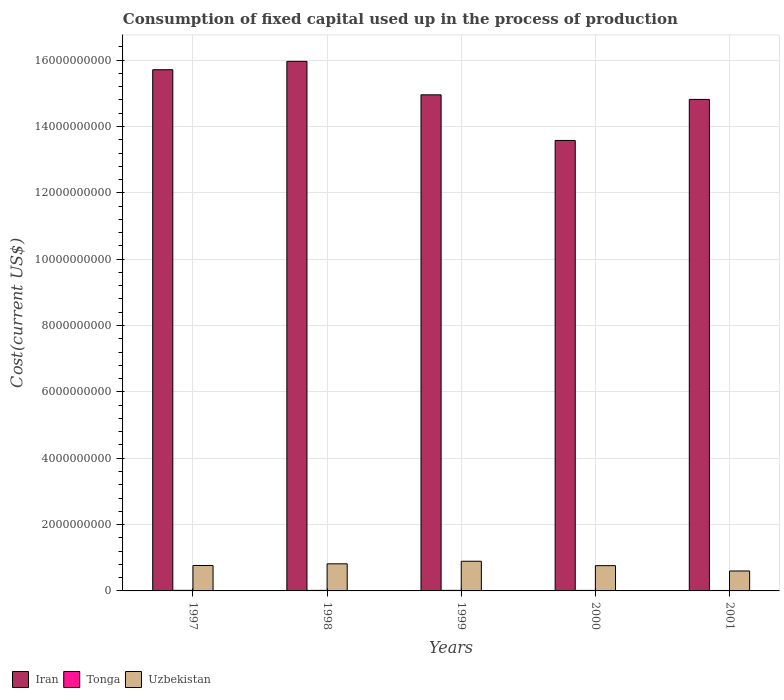How many different coloured bars are there?
Offer a very short reply. 3. Are the number of bars per tick equal to the number of legend labels?
Make the answer very short. Yes. How many bars are there on the 4th tick from the right?
Ensure brevity in your answer.  3. In how many cases, is the number of bars for a given year not equal to the number of legend labels?
Provide a short and direct response. 0. What is the amount consumed in the process of production in Iran in 2001?
Keep it short and to the point. 1.48e+1. Across all years, what is the maximum amount consumed in the process of production in Iran?
Give a very brief answer. 1.60e+1. Across all years, what is the minimum amount consumed in the process of production in Uzbekistan?
Keep it short and to the point. 6.01e+08. In which year was the amount consumed in the process of production in Iran minimum?
Keep it short and to the point. 2000. What is the total amount consumed in the process of production in Iran in the graph?
Keep it short and to the point. 7.50e+1. What is the difference between the amount consumed in the process of production in Uzbekistan in 1997 and that in 2001?
Make the answer very short. 1.64e+08. What is the difference between the amount consumed in the process of production in Uzbekistan in 1997 and the amount consumed in the process of production in Iran in 2001?
Offer a very short reply. -1.40e+1. What is the average amount consumed in the process of production in Iran per year?
Offer a terse response. 1.50e+1. In the year 1998, what is the difference between the amount consumed in the process of production in Tonga and amount consumed in the process of production in Uzbekistan?
Your answer should be very brief. -8.01e+08. What is the ratio of the amount consumed in the process of production in Iran in 2000 to that in 2001?
Your response must be concise. 0.92. What is the difference between the highest and the second highest amount consumed in the process of production in Iran?
Ensure brevity in your answer.  2.52e+08. What is the difference between the highest and the lowest amount consumed in the process of production in Uzbekistan?
Keep it short and to the point. 2.93e+08. What does the 2nd bar from the left in 1998 represents?
Make the answer very short. Tonga. What does the 1st bar from the right in 1999 represents?
Make the answer very short. Uzbekistan. Is it the case that in every year, the sum of the amount consumed in the process of production in Tonga and amount consumed in the process of production in Iran is greater than the amount consumed in the process of production in Uzbekistan?
Give a very brief answer. Yes. Does the graph contain grids?
Offer a terse response. Yes. How are the legend labels stacked?
Your answer should be very brief. Horizontal. What is the title of the graph?
Offer a terse response. Consumption of fixed capital used up in the process of production. What is the label or title of the X-axis?
Make the answer very short. Years. What is the label or title of the Y-axis?
Offer a very short reply. Cost(current US$). What is the Cost(current US$) in Iran in 1997?
Provide a short and direct response. 1.57e+1. What is the Cost(current US$) of Tonga in 1997?
Keep it short and to the point. 1.72e+07. What is the Cost(current US$) of Uzbekistan in 1997?
Your answer should be compact. 7.66e+08. What is the Cost(current US$) of Iran in 1998?
Your answer should be compact. 1.60e+1. What is the Cost(current US$) of Tonga in 1998?
Your answer should be compact. 1.61e+07. What is the Cost(current US$) in Uzbekistan in 1998?
Your response must be concise. 8.17e+08. What is the Cost(current US$) of Iran in 1999?
Give a very brief answer. 1.50e+1. What is the Cost(current US$) of Tonga in 1999?
Provide a short and direct response. 1.65e+07. What is the Cost(current US$) of Uzbekistan in 1999?
Keep it short and to the point. 8.94e+08. What is the Cost(current US$) of Iran in 2000?
Your response must be concise. 1.36e+1. What is the Cost(current US$) of Tonga in 2000?
Keep it short and to the point. 1.59e+07. What is the Cost(current US$) in Uzbekistan in 2000?
Your answer should be compact. 7.62e+08. What is the Cost(current US$) in Iran in 2001?
Offer a very short reply. 1.48e+1. What is the Cost(current US$) in Tonga in 2001?
Keep it short and to the point. 1.39e+07. What is the Cost(current US$) in Uzbekistan in 2001?
Offer a terse response. 6.01e+08. Across all years, what is the maximum Cost(current US$) in Iran?
Ensure brevity in your answer.  1.60e+1. Across all years, what is the maximum Cost(current US$) in Tonga?
Your response must be concise. 1.72e+07. Across all years, what is the maximum Cost(current US$) of Uzbekistan?
Your response must be concise. 8.94e+08. Across all years, what is the minimum Cost(current US$) of Iran?
Provide a short and direct response. 1.36e+1. Across all years, what is the minimum Cost(current US$) in Tonga?
Offer a terse response. 1.39e+07. Across all years, what is the minimum Cost(current US$) in Uzbekistan?
Your response must be concise. 6.01e+08. What is the total Cost(current US$) in Iran in the graph?
Provide a short and direct response. 7.50e+1. What is the total Cost(current US$) of Tonga in the graph?
Offer a very short reply. 7.96e+07. What is the total Cost(current US$) of Uzbekistan in the graph?
Your answer should be compact. 3.84e+09. What is the difference between the Cost(current US$) of Iran in 1997 and that in 1998?
Make the answer very short. -2.52e+08. What is the difference between the Cost(current US$) in Tonga in 1997 and that in 1998?
Keep it short and to the point. 1.14e+06. What is the difference between the Cost(current US$) of Uzbekistan in 1997 and that in 1998?
Your response must be concise. -5.13e+07. What is the difference between the Cost(current US$) of Iran in 1997 and that in 1999?
Ensure brevity in your answer.  7.57e+08. What is the difference between the Cost(current US$) of Tonga in 1997 and that in 1999?
Give a very brief answer. 7.30e+05. What is the difference between the Cost(current US$) in Uzbekistan in 1997 and that in 1999?
Offer a terse response. -1.29e+08. What is the difference between the Cost(current US$) of Iran in 1997 and that in 2000?
Offer a very short reply. 2.13e+09. What is the difference between the Cost(current US$) in Tonga in 1997 and that in 2000?
Ensure brevity in your answer.  1.25e+06. What is the difference between the Cost(current US$) of Uzbekistan in 1997 and that in 2000?
Your answer should be compact. 4.04e+06. What is the difference between the Cost(current US$) of Iran in 1997 and that in 2001?
Your answer should be compact. 8.96e+08. What is the difference between the Cost(current US$) in Tonga in 1997 and that in 2001?
Provide a short and direct response. 3.28e+06. What is the difference between the Cost(current US$) of Uzbekistan in 1997 and that in 2001?
Offer a terse response. 1.64e+08. What is the difference between the Cost(current US$) of Iran in 1998 and that in 1999?
Keep it short and to the point. 1.01e+09. What is the difference between the Cost(current US$) of Tonga in 1998 and that in 1999?
Offer a very short reply. -4.14e+05. What is the difference between the Cost(current US$) in Uzbekistan in 1998 and that in 1999?
Provide a short and direct response. -7.76e+07. What is the difference between the Cost(current US$) of Iran in 1998 and that in 2000?
Offer a very short reply. 2.38e+09. What is the difference between the Cost(current US$) in Tonga in 1998 and that in 2000?
Ensure brevity in your answer.  1.09e+05. What is the difference between the Cost(current US$) in Uzbekistan in 1998 and that in 2000?
Offer a very short reply. 5.54e+07. What is the difference between the Cost(current US$) in Iran in 1998 and that in 2001?
Your answer should be compact. 1.15e+09. What is the difference between the Cost(current US$) of Tonga in 1998 and that in 2001?
Your answer should be very brief. 2.14e+06. What is the difference between the Cost(current US$) in Uzbekistan in 1998 and that in 2001?
Make the answer very short. 2.16e+08. What is the difference between the Cost(current US$) in Iran in 1999 and that in 2000?
Offer a terse response. 1.38e+09. What is the difference between the Cost(current US$) of Tonga in 1999 and that in 2000?
Make the answer very short. 5.22e+05. What is the difference between the Cost(current US$) in Uzbekistan in 1999 and that in 2000?
Provide a succinct answer. 1.33e+08. What is the difference between the Cost(current US$) of Iran in 1999 and that in 2001?
Your response must be concise. 1.39e+08. What is the difference between the Cost(current US$) in Tonga in 1999 and that in 2001?
Your response must be concise. 2.55e+06. What is the difference between the Cost(current US$) of Uzbekistan in 1999 and that in 2001?
Provide a short and direct response. 2.93e+08. What is the difference between the Cost(current US$) in Iran in 2000 and that in 2001?
Provide a short and direct response. -1.24e+09. What is the difference between the Cost(current US$) in Tonga in 2000 and that in 2001?
Provide a succinct answer. 2.03e+06. What is the difference between the Cost(current US$) of Uzbekistan in 2000 and that in 2001?
Offer a terse response. 1.60e+08. What is the difference between the Cost(current US$) in Iran in 1997 and the Cost(current US$) in Tonga in 1998?
Your response must be concise. 1.57e+1. What is the difference between the Cost(current US$) of Iran in 1997 and the Cost(current US$) of Uzbekistan in 1998?
Your answer should be very brief. 1.49e+1. What is the difference between the Cost(current US$) of Tonga in 1997 and the Cost(current US$) of Uzbekistan in 1998?
Offer a very short reply. -8.00e+08. What is the difference between the Cost(current US$) in Iran in 1997 and the Cost(current US$) in Tonga in 1999?
Your answer should be compact. 1.57e+1. What is the difference between the Cost(current US$) of Iran in 1997 and the Cost(current US$) of Uzbekistan in 1999?
Provide a short and direct response. 1.48e+1. What is the difference between the Cost(current US$) in Tonga in 1997 and the Cost(current US$) in Uzbekistan in 1999?
Keep it short and to the point. -8.77e+08. What is the difference between the Cost(current US$) of Iran in 1997 and the Cost(current US$) of Tonga in 2000?
Your response must be concise. 1.57e+1. What is the difference between the Cost(current US$) in Iran in 1997 and the Cost(current US$) in Uzbekistan in 2000?
Ensure brevity in your answer.  1.49e+1. What is the difference between the Cost(current US$) of Tonga in 1997 and the Cost(current US$) of Uzbekistan in 2000?
Provide a succinct answer. -7.44e+08. What is the difference between the Cost(current US$) in Iran in 1997 and the Cost(current US$) in Tonga in 2001?
Give a very brief answer. 1.57e+1. What is the difference between the Cost(current US$) in Iran in 1997 and the Cost(current US$) in Uzbekistan in 2001?
Make the answer very short. 1.51e+1. What is the difference between the Cost(current US$) in Tonga in 1997 and the Cost(current US$) in Uzbekistan in 2001?
Offer a terse response. -5.84e+08. What is the difference between the Cost(current US$) in Iran in 1998 and the Cost(current US$) in Tonga in 1999?
Make the answer very short. 1.59e+1. What is the difference between the Cost(current US$) of Iran in 1998 and the Cost(current US$) of Uzbekistan in 1999?
Provide a succinct answer. 1.51e+1. What is the difference between the Cost(current US$) in Tonga in 1998 and the Cost(current US$) in Uzbekistan in 1999?
Offer a terse response. -8.78e+08. What is the difference between the Cost(current US$) in Iran in 1998 and the Cost(current US$) in Tonga in 2000?
Give a very brief answer. 1.59e+1. What is the difference between the Cost(current US$) of Iran in 1998 and the Cost(current US$) of Uzbekistan in 2000?
Make the answer very short. 1.52e+1. What is the difference between the Cost(current US$) in Tonga in 1998 and the Cost(current US$) in Uzbekistan in 2000?
Make the answer very short. -7.45e+08. What is the difference between the Cost(current US$) of Iran in 1998 and the Cost(current US$) of Tonga in 2001?
Keep it short and to the point. 1.59e+1. What is the difference between the Cost(current US$) in Iran in 1998 and the Cost(current US$) in Uzbekistan in 2001?
Ensure brevity in your answer.  1.54e+1. What is the difference between the Cost(current US$) of Tonga in 1998 and the Cost(current US$) of Uzbekistan in 2001?
Ensure brevity in your answer.  -5.85e+08. What is the difference between the Cost(current US$) of Iran in 1999 and the Cost(current US$) of Tonga in 2000?
Your answer should be compact. 1.49e+1. What is the difference between the Cost(current US$) of Iran in 1999 and the Cost(current US$) of Uzbekistan in 2000?
Provide a succinct answer. 1.42e+1. What is the difference between the Cost(current US$) in Tonga in 1999 and the Cost(current US$) in Uzbekistan in 2000?
Offer a terse response. -7.45e+08. What is the difference between the Cost(current US$) of Iran in 1999 and the Cost(current US$) of Tonga in 2001?
Provide a succinct answer. 1.49e+1. What is the difference between the Cost(current US$) in Iran in 1999 and the Cost(current US$) in Uzbekistan in 2001?
Give a very brief answer. 1.44e+1. What is the difference between the Cost(current US$) in Tonga in 1999 and the Cost(current US$) in Uzbekistan in 2001?
Your answer should be very brief. -5.85e+08. What is the difference between the Cost(current US$) in Iran in 2000 and the Cost(current US$) in Tonga in 2001?
Offer a very short reply. 1.36e+1. What is the difference between the Cost(current US$) in Iran in 2000 and the Cost(current US$) in Uzbekistan in 2001?
Give a very brief answer. 1.30e+1. What is the difference between the Cost(current US$) of Tonga in 2000 and the Cost(current US$) of Uzbekistan in 2001?
Provide a succinct answer. -5.85e+08. What is the average Cost(current US$) of Iran per year?
Your response must be concise. 1.50e+1. What is the average Cost(current US$) of Tonga per year?
Your answer should be compact. 1.59e+07. What is the average Cost(current US$) of Uzbekistan per year?
Keep it short and to the point. 7.68e+08. In the year 1997, what is the difference between the Cost(current US$) of Iran and Cost(current US$) of Tonga?
Keep it short and to the point. 1.57e+1. In the year 1997, what is the difference between the Cost(current US$) of Iran and Cost(current US$) of Uzbekistan?
Give a very brief answer. 1.49e+1. In the year 1997, what is the difference between the Cost(current US$) in Tonga and Cost(current US$) in Uzbekistan?
Ensure brevity in your answer.  -7.48e+08. In the year 1998, what is the difference between the Cost(current US$) of Iran and Cost(current US$) of Tonga?
Your response must be concise. 1.59e+1. In the year 1998, what is the difference between the Cost(current US$) of Iran and Cost(current US$) of Uzbekistan?
Ensure brevity in your answer.  1.51e+1. In the year 1998, what is the difference between the Cost(current US$) of Tonga and Cost(current US$) of Uzbekistan?
Ensure brevity in your answer.  -8.01e+08. In the year 1999, what is the difference between the Cost(current US$) of Iran and Cost(current US$) of Tonga?
Your answer should be compact. 1.49e+1. In the year 1999, what is the difference between the Cost(current US$) in Iran and Cost(current US$) in Uzbekistan?
Ensure brevity in your answer.  1.41e+1. In the year 1999, what is the difference between the Cost(current US$) of Tonga and Cost(current US$) of Uzbekistan?
Your answer should be very brief. -8.78e+08. In the year 2000, what is the difference between the Cost(current US$) in Iran and Cost(current US$) in Tonga?
Offer a terse response. 1.36e+1. In the year 2000, what is the difference between the Cost(current US$) of Iran and Cost(current US$) of Uzbekistan?
Offer a very short reply. 1.28e+1. In the year 2000, what is the difference between the Cost(current US$) of Tonga and Cost(current US$) of Uzbekistan?
Your answer should be very brief. -7.46e+08. In the year 2001, what is the difference between the Cost(current US$) in Iran and Cost(current US$) in Tonga?
Your answer should be compact. 1.48e+1. In the year 2001, what is the difference between the Cost(current US$) of Iran and Cost(current US$) of Uzbekistan?
Make the answer very short. 1.42e+1. In the year 2001, what is the difference between the Cost(current US$) of Tonga and Cost(current US$) of Uzbekistan?
Ensure brevity in your answer.  -5.87e+08. What is the ratio of the Cost(current US$) of Iran in 1997 to that in 1998?
Keep it short and to the point. 0.98. What is the ratio of the Cost(current US$) of Tonga in 1997 to that in 1998?
Your answer should be compact. 1.07. What is the ratio of the Cost(current US$) of Uzbekistan in 1997 to that in 1998?
Ensure brevity in your answer.  0.94. What is the ratio of the Cost(current US$) of Iran in 1997 to that in 1999?
Your answer should be compact. 1.05. What is the ratio of the Cost(current US$) in Tonga in 1997 to that in 1999?
Offer a terse response. 1.04. What is the ratio of the Cost(current US$) in Uzbekistan in 1997 to that in 1999?
Offer a terse response. 0.86. What is the ratio of the Cost(current US$) in Iran in 1997 to that in 2000?
Give a very brief answer. 1.16. What is the ratio of the Cost(current US$) of Tonga in 1997 to that in 2000?
Offer a terse response. 1.08. What is the ratio of the Cost(current US$) in Iran in 1997 to that in 2001?
Your answer should be very brief. 1.06. What is the ratio of the Cost(current US$) of Tonga in 1997 to that in 2001?
Provide a succinct answer. 1.24. What is the ratio of the Cost(current US$) of Uzbekistan in 1997 to that in 2001?
Offer a terse response. 1.27. What is the ratio of the Cost(current US$) in Iran in 1998 to that in 1999?
Give a very brief answer. 1.07. What is the ratio of the Cost(current US$) of Tonga in 1998 to that in 1999?
Keep it short and to the point. 0.97. What is the ratio of the Cost(current US$) of Uzbekistan in 1998 to that in 1999?
Keep it short and to the point. 0.91. What is the ratio of the Cost(current US$) in Iran in 1998 to that in 2000?
Your response must be concise. 1.18. What is the ratio of the Cost(current US$) of Tonga in 1998 to that in 2000?
Offer a very short reply. 1.01. What is the ratio of the Cost(current US$) of Uzbekistan in 1998 to that in 2000?
Offer a terse response. 1.07. What is the ratio of the Cost(current US$) of Iran in 1998 to that in 2001?
Your answer should be very brief. 1.08. What is the ratio of the Cost(current US$) in Tonga in 1998 to that in 2001?
Your response must be concise. 1.15. What is the ratio of the Cost(current US$) in Uzbekistan in 1998 to that in 2001?
Keep it short and to the point. 1.36. What is the ratio of the Cost(current US$) of Iran in 1999 to that in 2000?
Keep it short and to the point. 1.1. What is the ratio of the Cost(current US$) in Tonga in 1999 to that in 2000?
Your response must be concise. 1.03. What is the ratio of the Cost(current US$) in Uzbekistan in 1999 to that in 2000?
Give a very brief answer. 1.17. What is the ratio of the Cost(current US$) in Iran in 1999 to that in 2001?
Keep it short and to the point. 1.01. What is the ratio of the Cost(current US$) of Tonga in 1999 to that in 2001?
Offer a very short reply. 1.18. What is the ratio of the Cost(current US$) of Uzbekistan in 1999 to that in 2001?
Provide a succinct answer. 1.49. What is the ratio of the Cost(current US$) of Iran in 2000 to that in 2001?
Your answer should be compact. 0.92. What is the ratio of the Cost(current US$) of Tonga in 2000 to that in 2001?
Keep it short and to the point. 1.15. What is the ratio of the Cost(current US$) in Uzbekistan in 2000 to that in 2001?
Provide a short and direct response. 1.27. What is the difference between the highest and the second highest Cost(current US$) of Iran?
Offer a terse response. 2.52e+08. What is the difference between the highest and the second highest Cost(current US$) in Tonga?
Your answer should be very brief. 7.30e+05. What is the difference between the highest and the second highest Cost(current US$) of Uzbekistan?
Give a very brief answer. 7.76e+07. What is the difference between the highest and the lowest Cost(current US$) in Iran?
Give a very brief answer. 2.38e+09. What is the difference between the highest and the lowest Cost(current US$) in Tonga?
Offer a very short reply. 3.28e+06. What is the difference between the highest and the lowest Cost(current US$) of Uzbekistan?
Offer a terse response. 2.93e+08. 